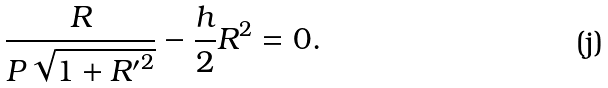<formula> <loc_0><loc_0><loc_500><loc_500>\frac { R } { P \sqrt { 1 + { R ^ { \prime } } ^ { 2 } } } - \frac { h } { 2 } R ^ { 2 } = 0 .</formula> 